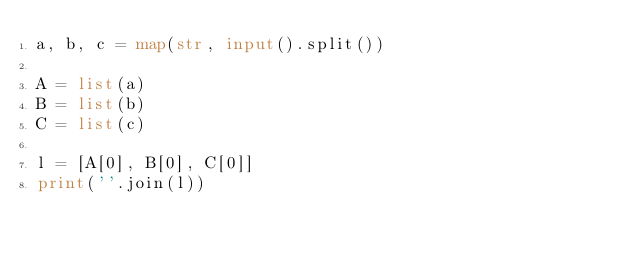Convert code to text. <code><loc_0><loc_0><loc_500><loc_500><_Python_>a, b, c = map(str, input().split())

A = list(a)
B = list(b)
C = list(c)

l = [A[0], B[0], C[0]]
print(''.join(l))</code> 